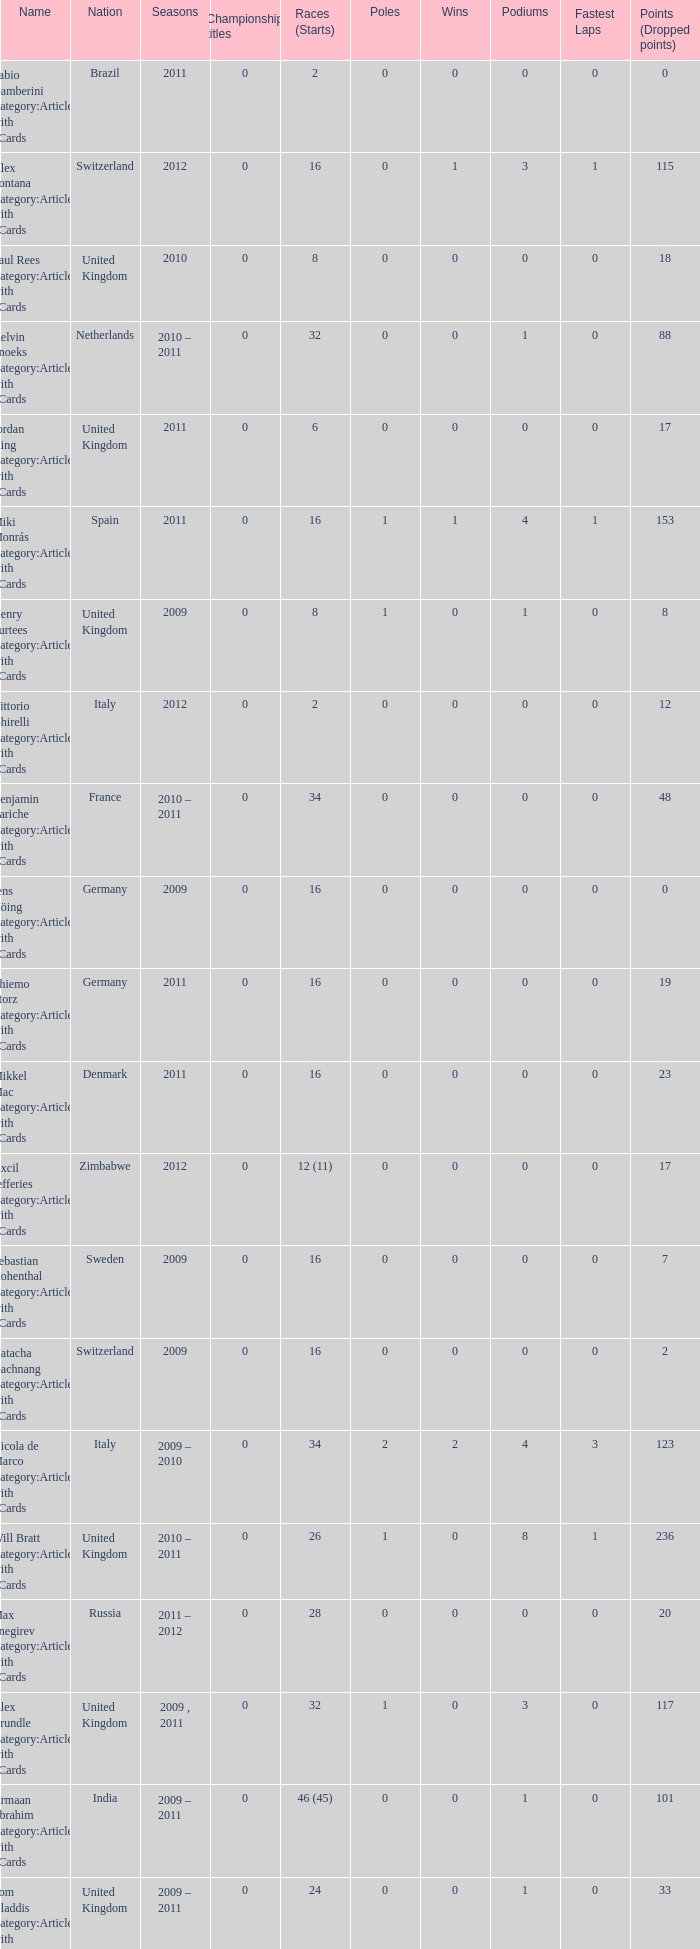Could you parse the entire table? {'header': ['Name', 'Nation', 'Seasons', 'Championship titles', 'Races (Starts)', 'Poles', 'Wins', 'Podiums', 'Fastest Laps', 'Points (Dropped points)'], 'rows': [['Fabio Gamberini Category:Articles with hCards', 'Brazil', '2011', '0', '2', '0', '0', '0', '0', '0'], ['Alex Fontana Category:Articles with hCards', 'Switzerland', '2012', '0', '16', '0', '1', '3', '1', '115'], ['Paul Rees Category:Articles with hCards', 'United Kingdom', '2010', '0', '8', '0', '0', '0', '0', '18'], ['Kelvin Snoeks Category:Articles with hCards', 'Netherlands', '2010 – 2011', '0', '32', '0', '0', '1', '0', '88'], ['Jordan King Category:Articles with hCards', 'United Kingdom', '2011', '0', '6', '0', '0', '0', '0', '17'], ['Miki Monrás Category:Articles with hCards', 'Spain', '2011', '0', '16', '1', '1', '4', '1', '153'], ['Henry Surtees Category:Articles with hCards', 'United Kingdom', '2009', '0', '8', '1', '0', '1', '0', '8'], ['Vittorio Ghirelli Category:Articles with hCards', 'Italy', '2012', '0', '2', '0', '0', '0', '0', '12'], ['Benjamin Lariche Category:Articles with hCards', 'France', '2010 – 2011', '0', '34', '0', '0', '0', '0', '48'], ['Jens Höing Category:Articles with hCards', 'Germany', '2009', '0', '16', '0', '0', '0', '0', '0'], ['Thiemo Storz Category:Articles with hCards', 'Germany', '2011', '0', '16', '0', '0', '0', '0', '19'], ['Mikkel Mac Category:Articles with hCards', 'Denmark', '2011', '0', '16', '0', '0', '0', '0', '23'], ['Axcil Jefferies Category:Articles with hCards', 'Zimbabwe', '2012', '0', '12 (11)', '0', '0', '0', '0', '17'], ['Sebastian Hohenthal Category:Articles with hCards', 'Sweden', '2009', '0', '16', '0', '0', '0', '0', '7'], ['Natacha Gachnang Category:Articles with hCards', 'Switzerland', '2009', '0', '16', '0', '0', '0', '0', '2'], ['Nicola de Marco Category:Articles with hCards', 'Italy', '2009 – 2010', '0', '34', '2', '2', '4', '3', '123'], ['Will Bratt Category:Articles with hCards', 'United Kingdom', '2010 – 2011', '0', '26', '1', '0', '8', '1', '236'], ['Max Snegirev Category:Articles with hCards', 'Russia', '2011 – 2012', '0', '28', '0', '0', '0', '0', '20'], ['Alex Brundle Category:Articles with hCards', 'United Kingdom', '2009 , 2011', '0', '32', '1', '0', '3', '0', '117'], ['Armaan Ebrahim Category:Articles with hCards', 'India', '2009 – 2011', '0', '46 (45)', '0', '0', '1', '0', '101'], ['Tom Gladdis Category:Articles with hCards', 'United Kingdom', '2009 – 2011', '0', '24', '0', '0', '1', '0', '33'], ['Andy Soucek Category:Articles with hCards', 'Spain', '2009', '1 ( 2009 )', '16', '2', '7', '11', '3', '115'], ['Christopher Zanella Category:Articles with hCards', 'Switzerland', '2011 – 2012', '0', '32', '3', '4', '14', '5', '385 (401)'], ['Mihai Marinescu Category:Articles with hCards', 'Romania', '2010 – 2012', '0', '50', '4', '3', '8', '4', '299'], ['Julian Theobald Category:Articles with hCards', 'Germany', '2010 – 2011', '0', '18', '0', '0', '0', '0', '8'], ['Robert Wickens Category:Articles with hCards', 'Canada', '2009', '0', '16', '5', '2', '6', '3', '64'], ['Henri Karjalainen Category:Articles with hCards', 'Finland', '2009', '0', '16', '0', '0', '0', '0', '7'], ['Ivan Samarin Category:Articles with hCards', 'Russia', '2010', '0', '18', '0', '0', '0', '0', '64'], ['Kourosh Khani Category:Articles with hCards', 'Iran', '2012', '0', '8', '0', '0', '0', '0', '2'], ['Jon Lancaster Category:Articles with hCards', 'United Kingdom', '2011', '0', '2', '0', '0', '0', '0', '14'], ['Jack Clarke Category:Articles with hCards', 'United Kingdom', '2009 – 2011', '0', '50 (49)', '0', '1', '3', '1', '197'], ['Samuele Buttarelli Category:Articles with hCards', 'Italy', '2012', '0', '2', '0', '0', '0', '0', '0'], ['Natalia Kowalska Category:Articles with hCards', 'Poland', '2010 – 2011', '0', '20', '0', '0', '0', '0', '3'], ['Edoardo Piscopo Category:Articles with hCards', 'Italy', '2009', '0', '14', '0', '0', '0', '0', '19'], ['Ollie Hancock Category:Articles with hCards', 'United Kingdom', '2009', '0', '6', '0', '0', '0', '0', '0'], ['Jason Moore Category:Articles with hCards', 'United Kingdom', '2009', '0', '16 (15)', '0', '0', '0', '0', '3'], ['Mirko Bortolotti Category:Articles with hCards', 'Italy', '2009 , 2011', '1 ( 2011 )', '32', '7', '8', '19', '8', '339 (366)'], ['Miloš Pavlović Category:Articles with hCards', 'Serbia', '2009', '0', '16', '0', '0', '2', '1', '29'], ['Benjamin Bailly Category:Articles with hCards', 'Belgium', '2010', '0', '18', '1', '1', '3', '0', '130'], ['Parthiva Sureshwaren Category:Articles with hCards', 'India', '2010 – 2012', '0', '32 (31)', '0', '0', '0', '0', '1'], ['Jolyon Palmer Category:Articles with hCards', 'United Kingdom', '2009 – 2010', '0', '34 (36)', '5', '5', '10', '3', '245'], ['Kazim Vasiliauskas Category:Articles with hCards', 'Lithuania', '2009 – 2010', '0', '34', '3', '2', '10', '4', '198'], ['Dino Zamparelli Category:Articles with hCards', 'United Kingdom', '2012', '0', '16', '0', '0', '2', '0', '106.5'], ['Julien Jousse Category:Articles with hCards', 'France', '2009', '0', '16', '1', '1', '4', '2', '49'], ['Mathéo Tuscher Category:Articles with hCards', 'Switzerland', '2012', '0', '16', '4', '2', '9', '1', '210'], ['René Binder Category:Articles with hCards', 'Austria', '2011', '0', '2', '0', '0', '0', '0', '0'], ['Mauro Calamia Category:Articles with hCards', 'Switzerland', '2012', '0', '12', '0', '0', '0', '0', '2'], ['Johan Jokinen Category:Articles with hCards', 'Denmark', '2010', '0', '6', '0', '0', '1', '1', '21'], ['Mikhail Aleshin Category:Articles with hCards', 'Russia', '2009', '0', '16', '1', '1', '5', '0', '59'], ['Sung-Hak Mun Category:Articles with hCards', 'South Korea', '2011', '0', '16 (15)', '0', '0', '0', '0', '0'], ['Markus Pommer Category:Articles with hCards', 'Germany', '2012', '0', '16', '4', '3', '5', '2', '169'], ['Luciano Bacheta Category:Articles with hCards', 'United Kingdom', '2011 – 2012', '1 ( 2012 )', '20', '3', '5', '10', '5', '249.5 (253.5)'], ['José Luis Abadín Category:Articles with hCards', 'Spain', '2011 – 2012', '0', '12', '0', '0', '0', '0', '1'], ['Tristan Vautier Category:Articles with hCards', 'France', '2009', '0', '2', '0', '0', '1', '0', '9'], ['Philipp Eng Category:Articles with hCards', 'Austria', '2009 – 2010', '0', '34', '3', '4', '7', '1', '181'], ['Pietro Gandolfi Category:Articles with hCards', 'Italy', '2009', '0', '16', '0', '0', '0', '0', '0'], ['Kevin Mirocha Category:Articles with hCards', 'Poland', '2012', '0', '16', '1', '1', '6', '0', '159.5'], ['Victor Guerin Category:Articles with hCards', 'Brazil', '2012', '0', '2', '0', '0', '0', '0', '2'], ['Ramón Piñeiro Category:Articles with hCards', 'Spain', '2010 – 2011', '0', '18', '2', '3', '7', '2', '186'], ['Daniel McKenzie Category:Articles with hCards', 'United Kingdom', '2012', '0', '16', '0', '0', '2', '0', '95'], ['Dean Stoneman Category:Articles with hCards', 'United Kingdom', '2010', '1 ( 2010 )', '18', '6', '6', '13', '6', '284'], ['Germán Sánchez Category:Articles with hCards', 'Spain', '2009', '0', '16 (14)', '0', '0', '0', '0', '2'], ['Carlos Iaconelli Category:Articles with hCards', 'Brazil', '2009', '0', '14', '0', '0', '1', '0', '21'], ['Ajith Kumar Category:Articles with hCards', 'India', '2010', '0', '6', '0', '0', '0', '0', '0'], ['Harald Schlegelmilch Category:Articles with hCards', 'Latvia', '2012', '0', '2', '0', '0', '0', '0', '12'], ['Sergey Afanasyev Category:Articles with hCards', 'Russia', '2010', '0', '18', '1', '0', '4', '1', '157'], ['Plamen Kralev Category:Articles with hCards', 'Bulgaria', '2010 – 2012', '0', '50 (49)', '0', '0', '0', '0', '6'], ['Hector Hurst Category:Articles with hCards', 'United Kingdom', '2012', '0', '16', '0', '0', '0', '0', '27'], ['Richard Gonda Category:Articles with hCards', 'Slovakia', '2012', '0', '2', '0', '0', '0', '0', '4'], ['Johannes Theobald Category:Articles with hCards', 'Germany', '2010 – 2011', '0', '14', '0', '0', '0', '0', '1'], ['Ricardo Teixeira Category:Articles with hCards', 'Angola', '2010', '0', '18', '0', '0', '0', '0', '23'], ['Tobias Hegewald Category:Articles with hCards', 'Germany', '2009 , 2011', '0', '32', '4', '2', '5', '3', '158']]} What were the starts when the points dropped 18? 8.0. 